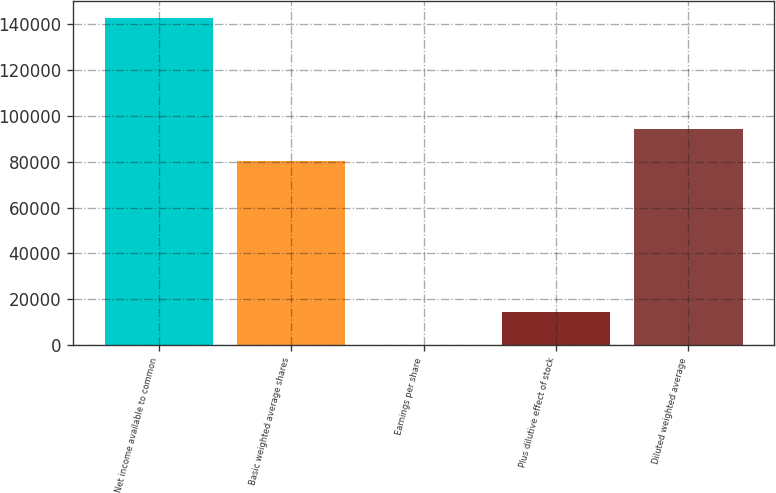Convert chart. <chart><loc_0><loc_0><loc_500><loc_500><bar_chart><fcel>Net income available to common<fcel>Basic weighted average shares<fcel>Earnings per share<fcel>Plus dilutive effect of stock<fcel>Diluted weighted average<nl><fcel>142985<fcel>80229<fcel>1.78<fcel>14300.1<fcel>94527.3<nl></chart> 